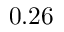<formula> <loc_0><loc_0><loc_500><loc_500>0 . 2 6</formula> 